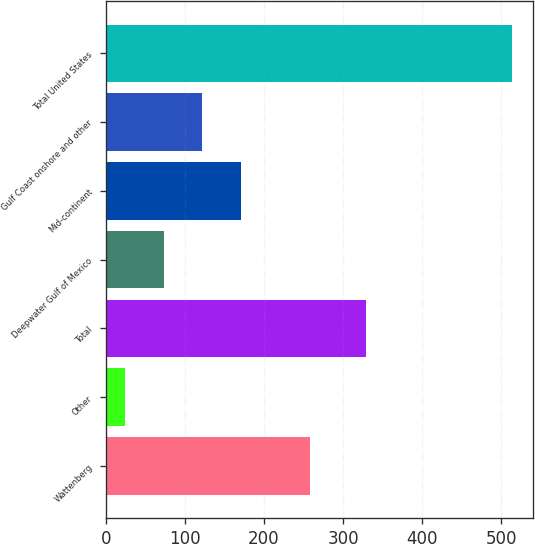Convert chart to OTSL. <chart><loc_0><loc_0><loc_500><loc_500><bar_chart><fcel>Wattenberg<fcel>Other<fcel>Total<fcel>Deepwater Gulf of Mexico<fcel>Mid-continent<fcel>Gulf Coast onshore and other<fcel>Total United States<nl><fcel>258<fcel>24<fcel>329<fcel>73<fcel>171<fcel>122<fcel>514<nl></chart> 